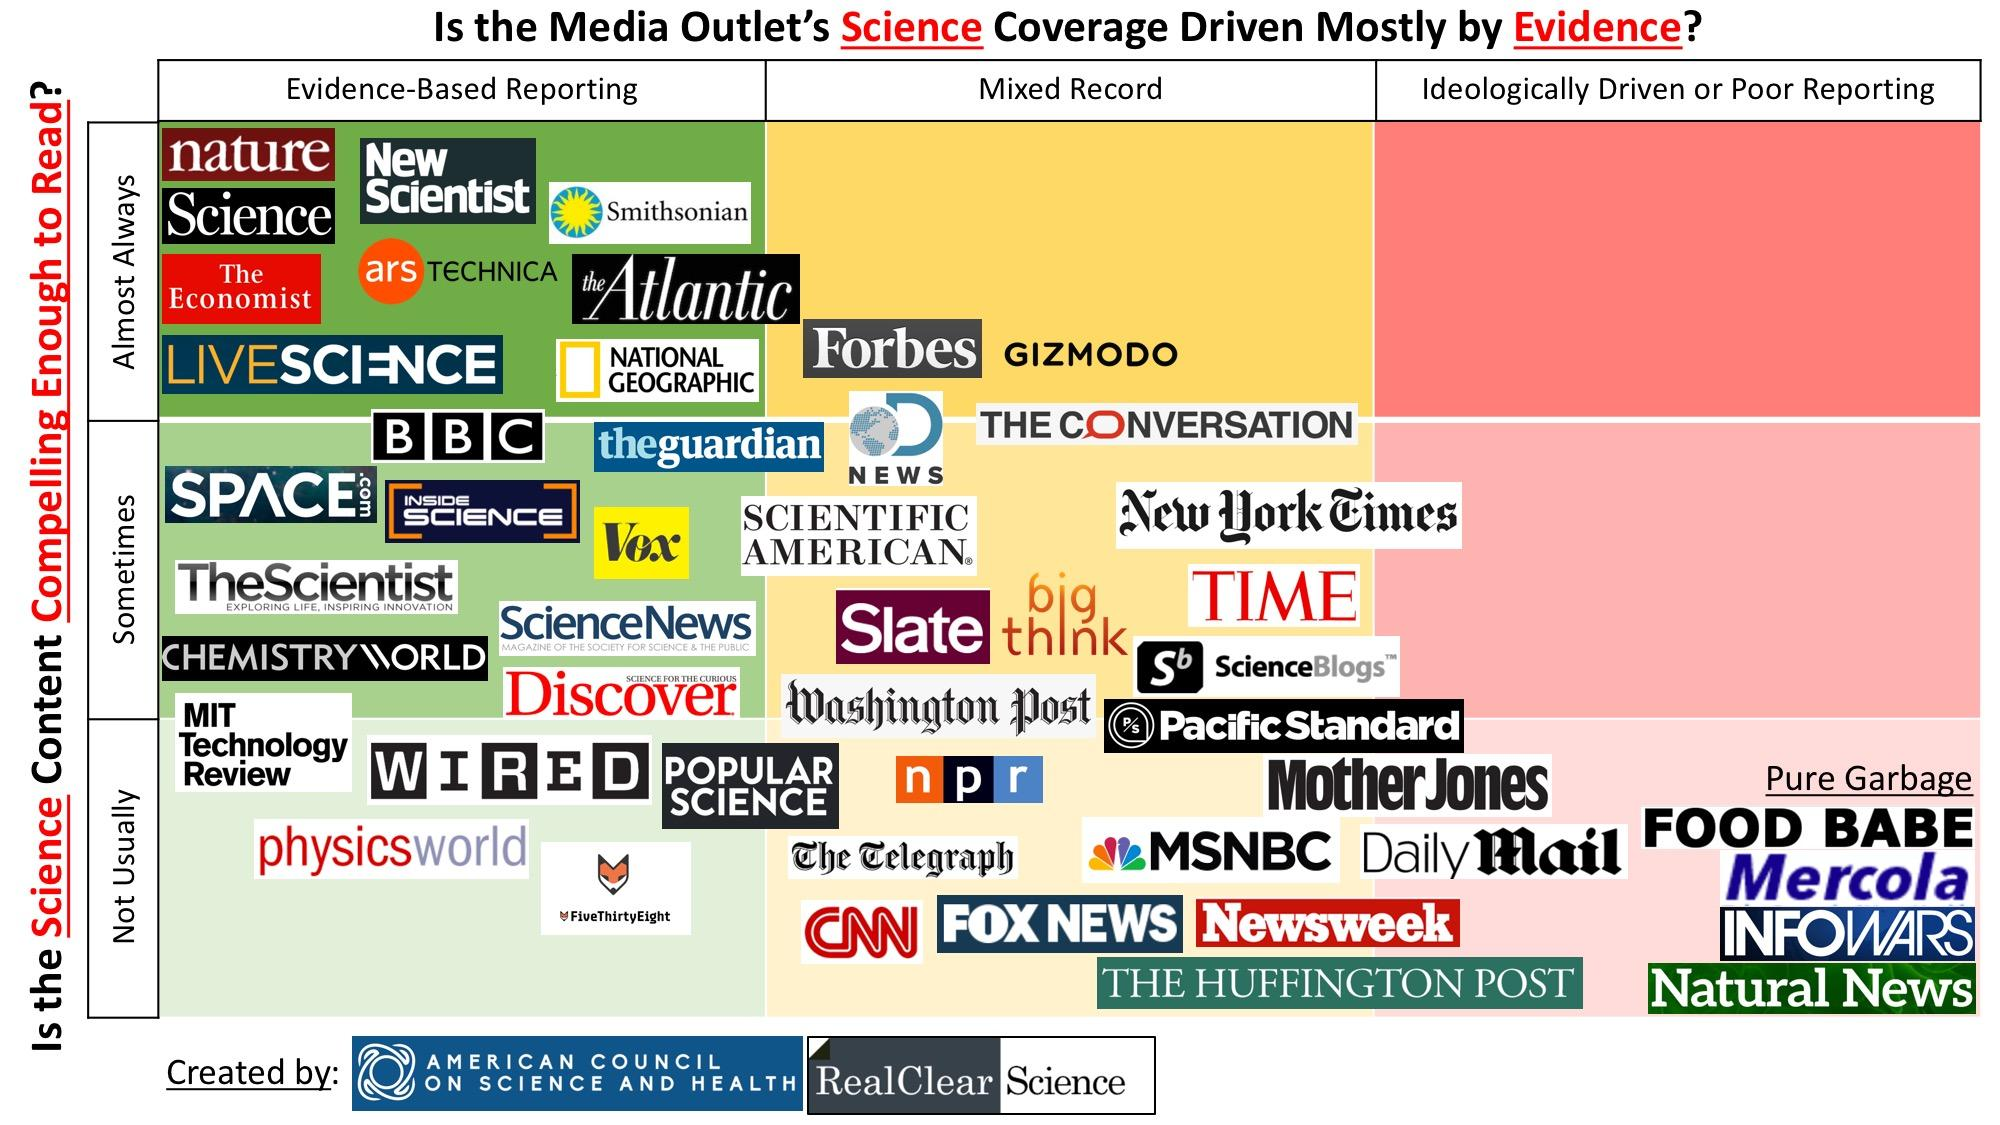Identify some key points in this picture. Slate has a mixed record when it comes to reporting. Big Think has a mixed record of reporting, sometimes. Vox often conducts evidence-based reporting, but it is not always clear what type of reporting they provide. New Scientist almost always engages in evidence-based reporting. It is not common for media outlets to have poor reporting almost always. 